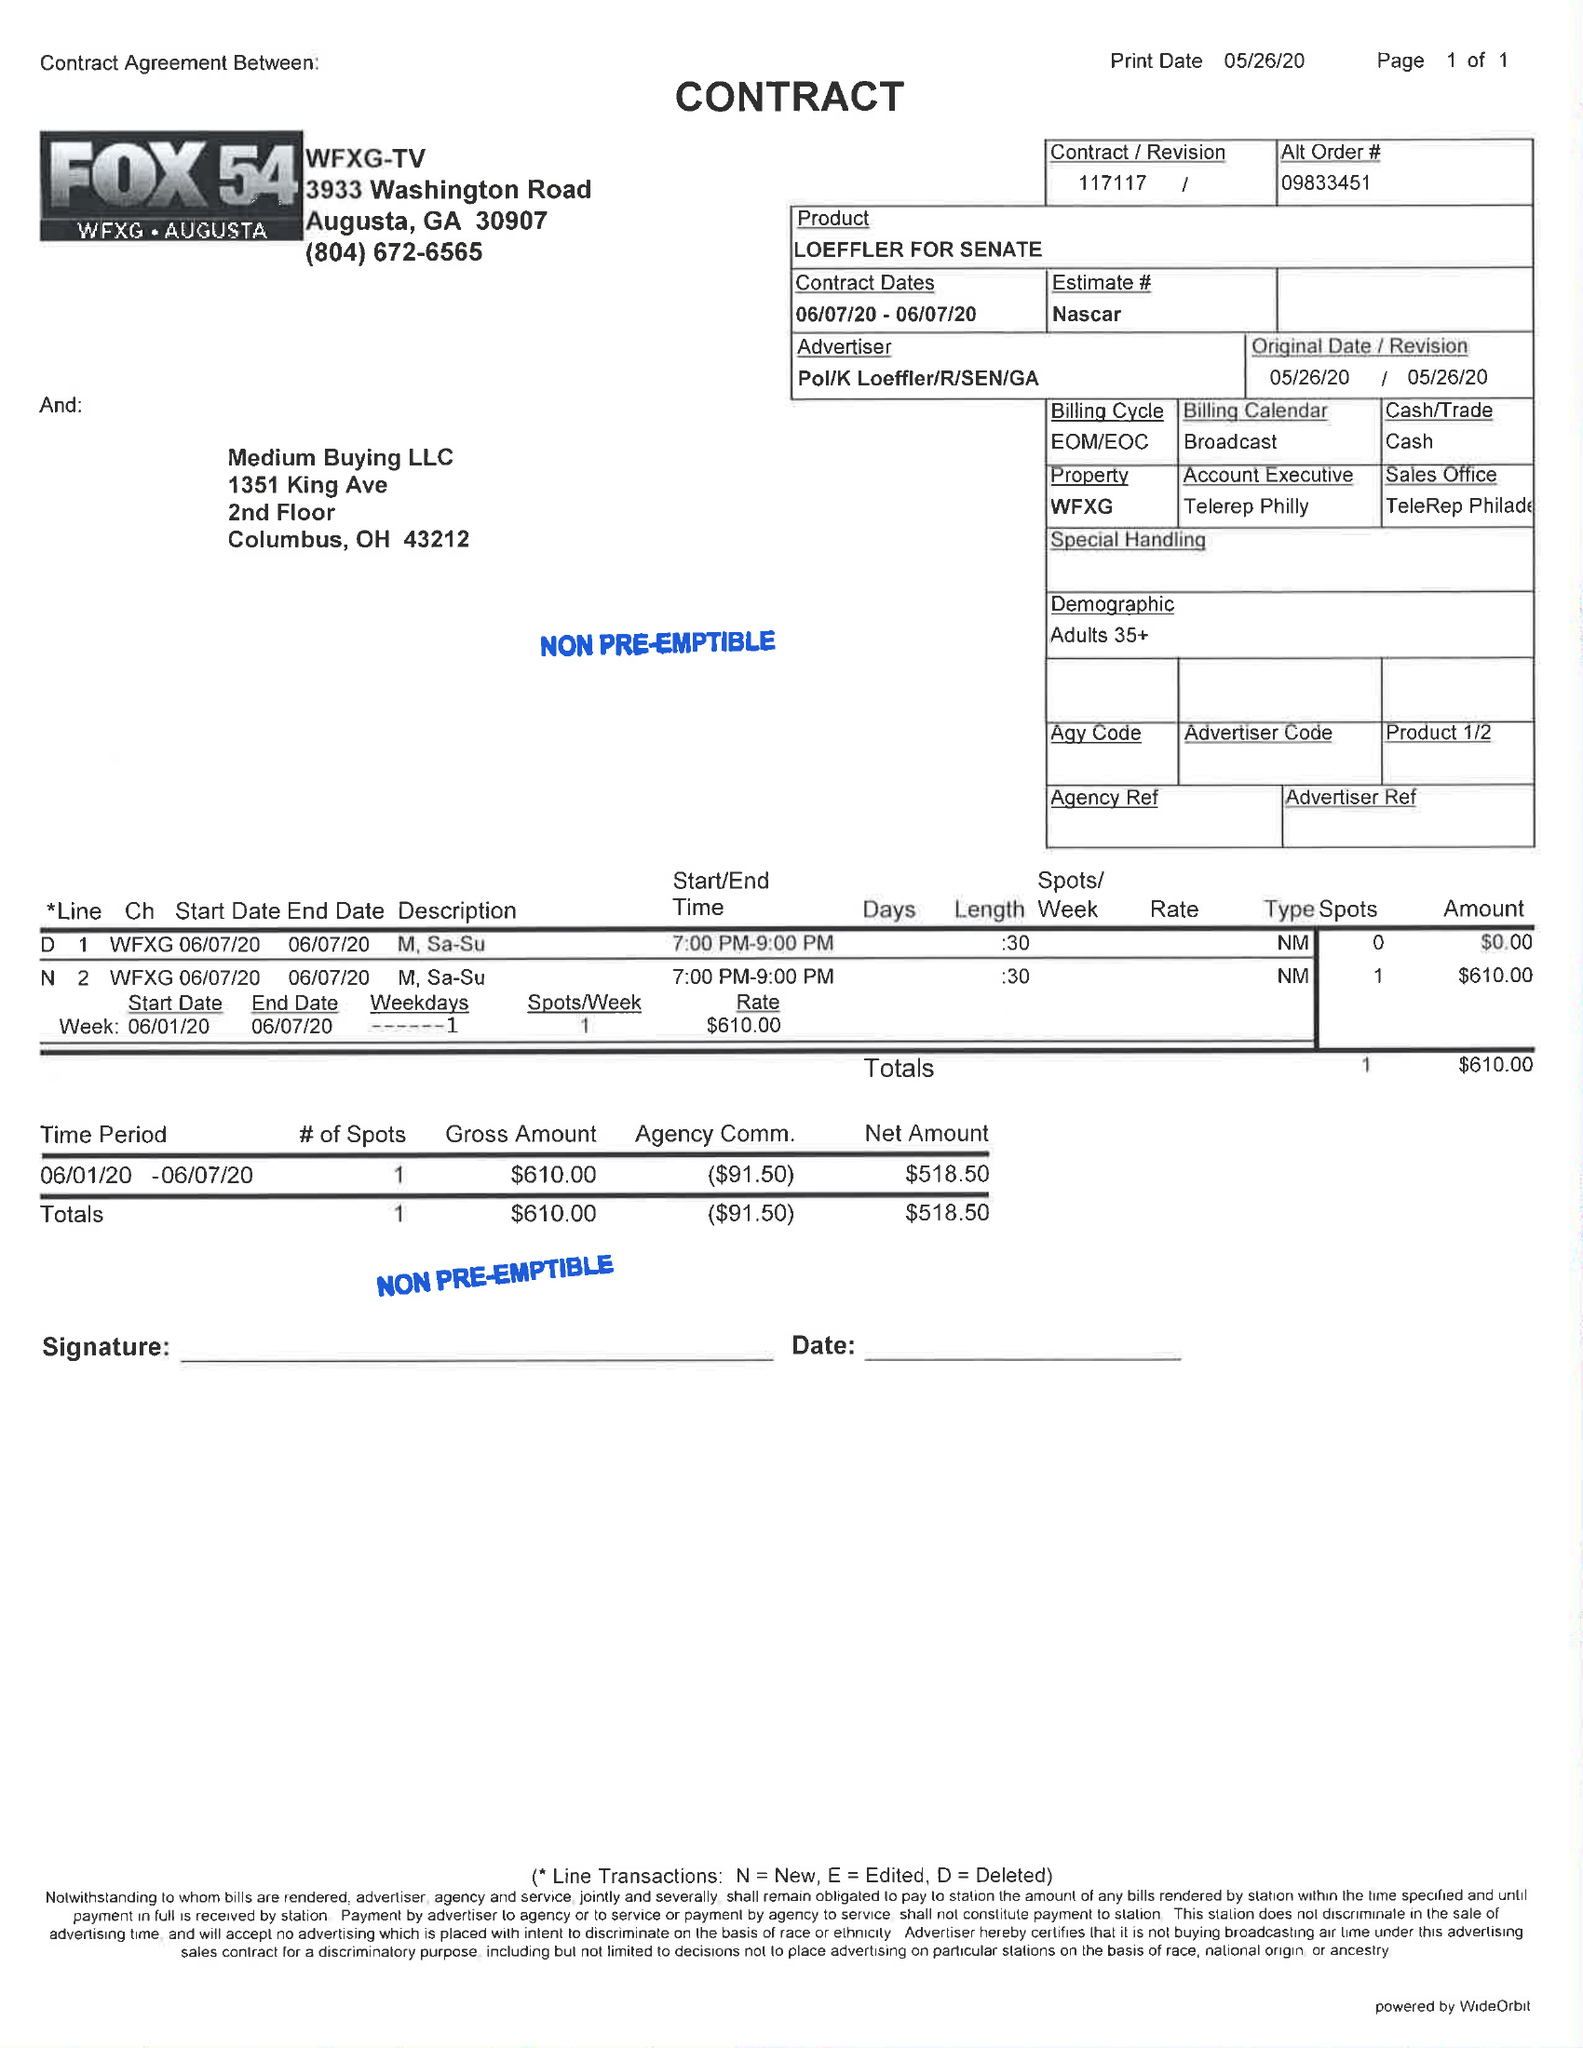What is the value for the gross_amount?
Answer the question using a single word or phrase. 610.00 